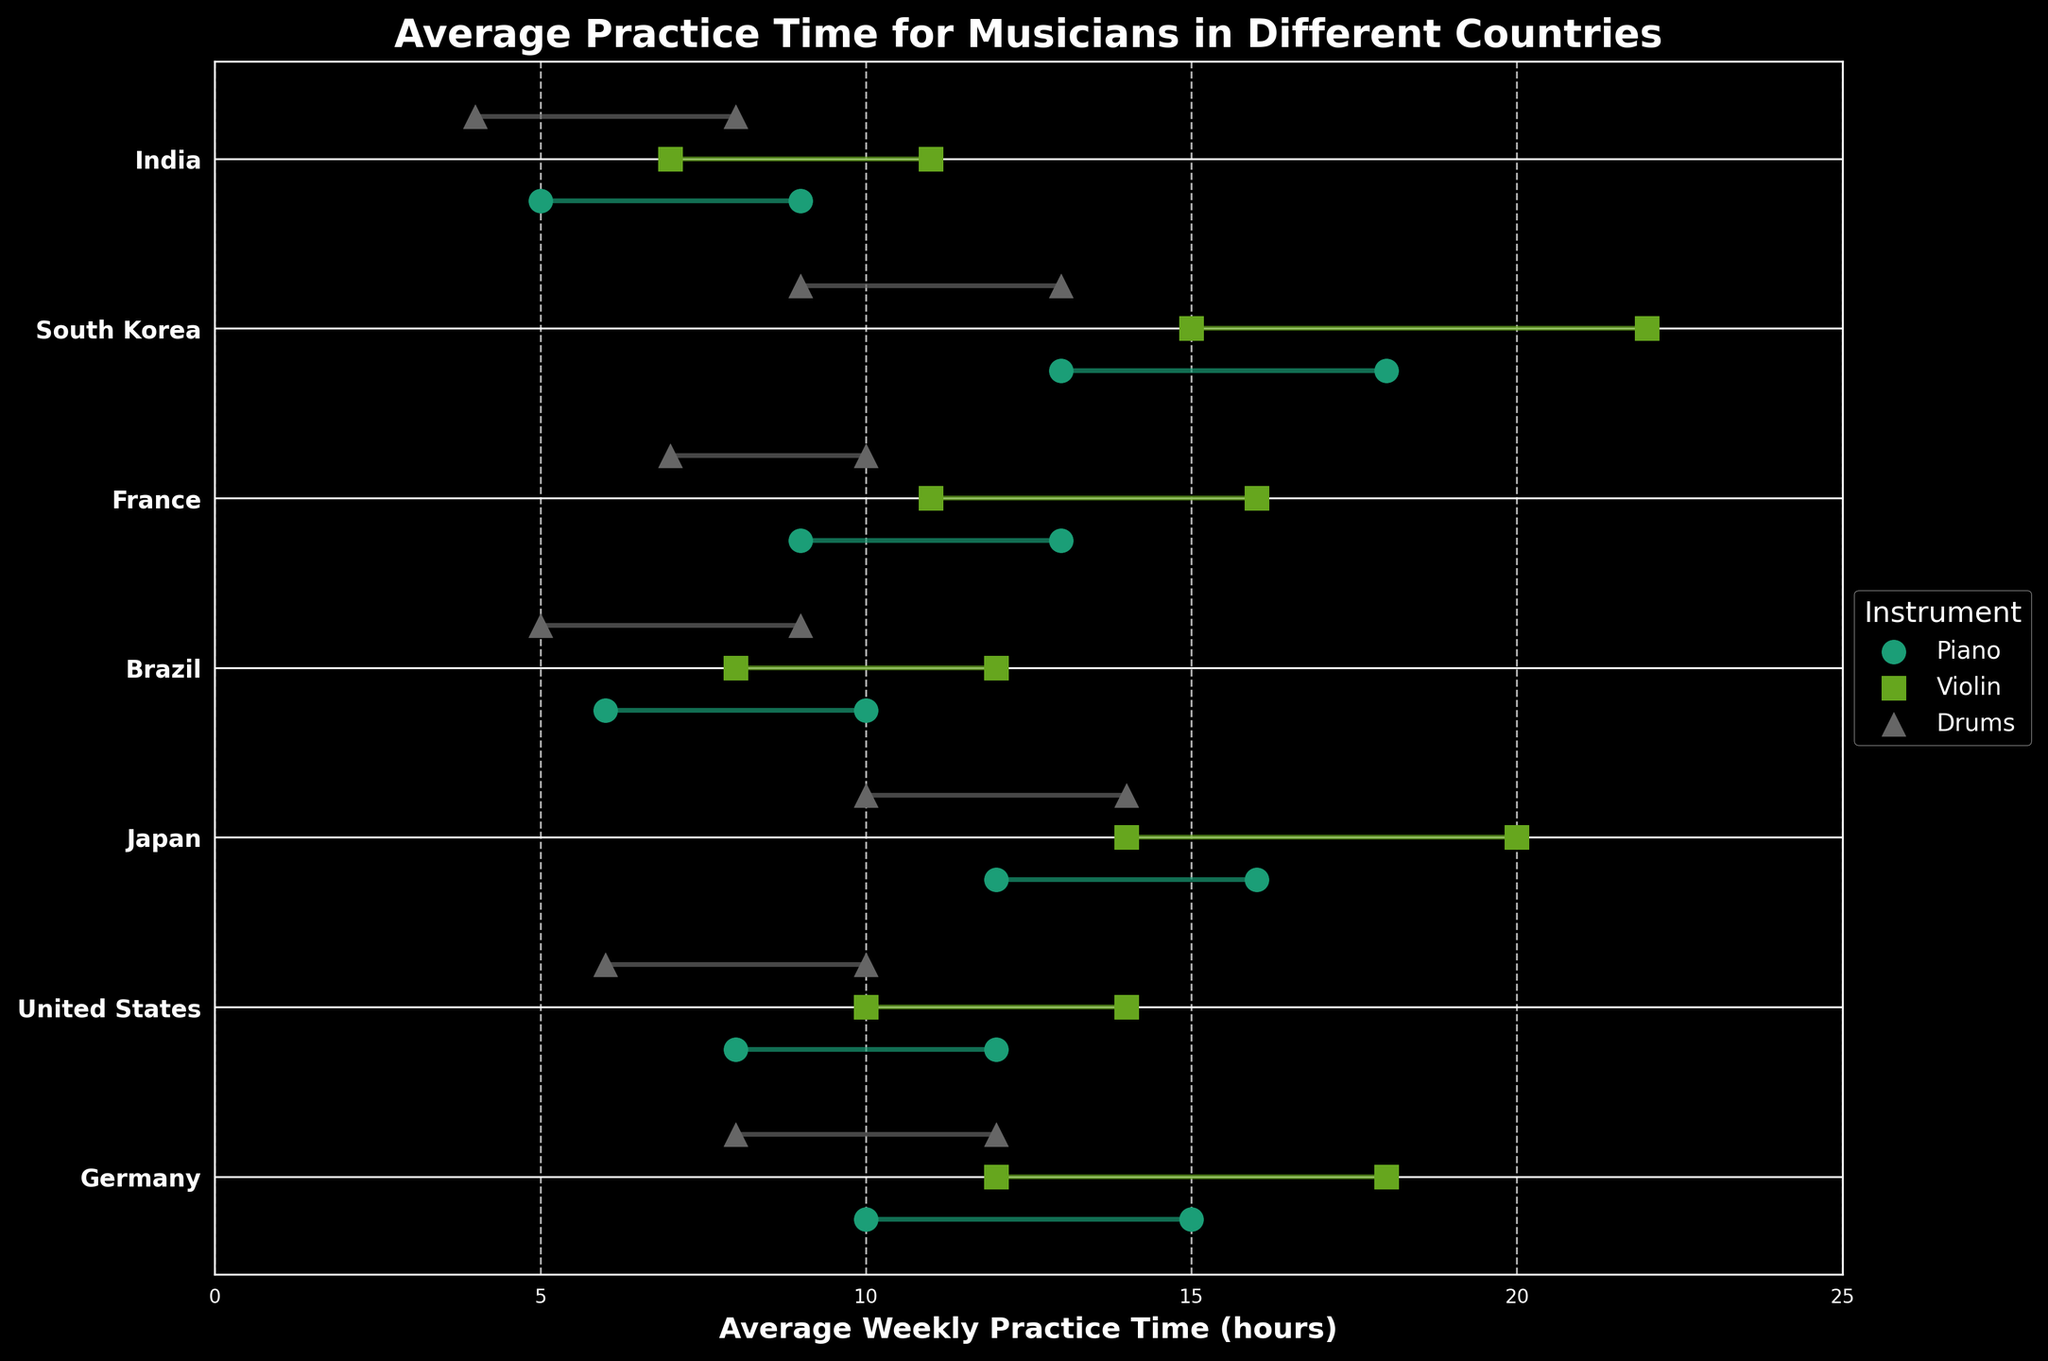What is the title of the plot? The title of the plot is usually found at the top of the figure. In this case, it is "Average Practice Time for Musicians in Different Countries".
Answer: "Average Practice Time for Musicians in Different Countries" Which instrument in Germany has the highest average weekly practice time range? By looking at the ranges for each instrument in Germany, we can see that the violin has the highest range of 12-18 hours.
Answer: Violin What is the minimum average weekly practice time for instruments in Brazil? We need to identify the smallest starting point within the ranges for each instrument in Brazil. The drums have the smallest starting point at 5 hours.
Answer: 5 hours How many instruments are practiced in Japan? By looking at the figure, we identify that three instruments are practiced in Japan: Piano, Violin, and Drums.
Answer: 3 Which country has the highest maximum average weekly practice time for any instrument, and what is that time? By looking at the maximum endpoints of all practice time ranges, South Korea's Violin has the highest with 22 hours.
Answer: South Korea, 22 hours Between Piano and Drums in the United States, which has a higher average weekly practice time range? For Piano in the United States, the range is 8-12 hours, and for Drums, it is 6-10 hours. The Piano has a higher range.
Answer: Piano Which instrument has the highest lower bound of average weekly practice time across all countries? By checking the lower bounds for all instruments, the Violin in South Korea has the highest lower bound of 15 hours.
Answer: Violin What is the range of average weekly practice time for the Drums in France? The practice time range for Drums in France is shown as 7-10 hours.
Answer: 7-10 hours How does the average weekly practice time range for Violin in India compare to that in Japan? In India, the Violin's range is 7-11 hours, and in Japan, it is 14-20 hours. Therefore, Japan has a much larger range.
Answer: Japan's range is larger 